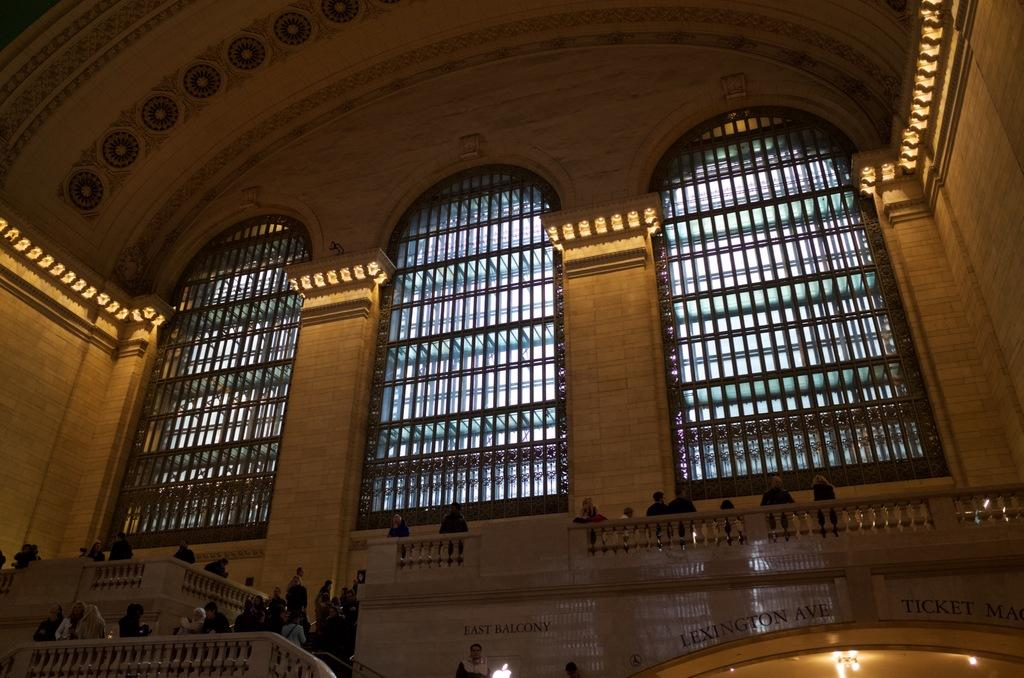What type of structures can be seen in the image? There are walls, pillars, windows, and concrete grills in the image. What might be used to support the structure or provide ventilation? The pillars and windows, respectively, serve these purposes in the image. What material are the grills made of? The concrete grills are made of concrete. Are there any people present in the image? Yes, there are persons standing beside the walls, pillars, windows, or concrete grills in the image. What type of drum can be seen in the image? There is no drum present in the image. Are there any beds visible in the image? There are no beds visible in the image. 